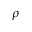Convert formula to latex. <formula><loc_0><loc_0><loc_500><loc_500>\rho</formula> 